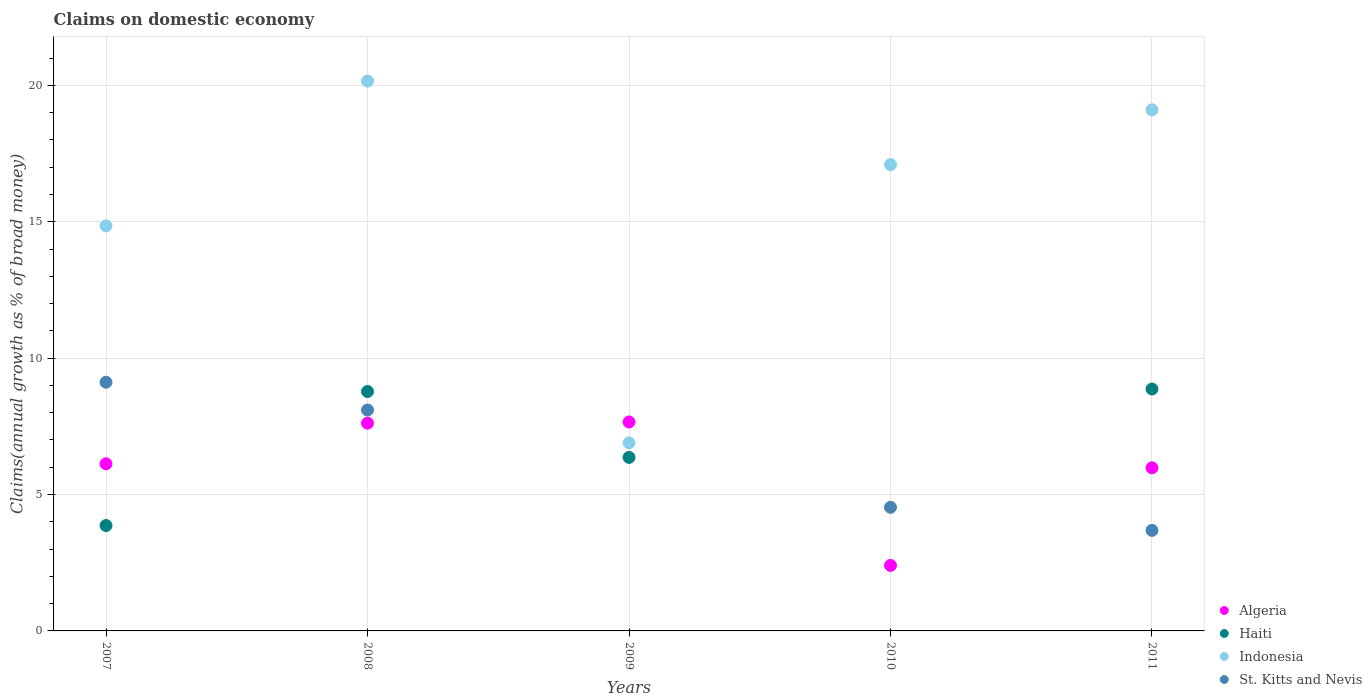How many different coloured dotlines are there?
Provide a succinct answer. 4. Is the number of dotlines equal to the number of legend labels?
Your answer should be compact. No. Across all years, what is the maximum percentage of broad money claimed on domestic economy in Indonesia?
Offer a terse response. 20.16. In which year was the percentage of broad money claimed on domestic economy in Algeria maximum?
Ensure brevity in your answer.  2009. What is the total percentage of broad money claimed on domestic economy in Indonesia in the graph?
Keep it short and to the point. 78.1. What is the difference between the percentage of broad money claimed on domestic economy in St. Kitts and Nevis in 2008 and that in 2010?
Your answer should be compact. 3.57. What is the difference between the percentage of broad money claimed on domestic economy in Algeria in 2010 and the percentage of broad money claimed on domestic economy in St. Kitts and Nevis in 2009?
Your answer should be compact. 2.4. What is the average percentage of broad money claimed on domestic economy in Haiti per year?
Provide a short and direct response. 5.57. In the year 2009, what is the difference between the percentage of broad money claimed on domestic economy in Haiti and percentage of broad money claimed on domestic economy in Indonesia?
Make the answer very short. -0.53. In how many years, is the percentage of broad money claimed on domestic economy in Haiti greater than 3 %?
Give a very brief answer. 4. What is the ratio of the percentage of broad money claimed on domestic economy in Indonesia in 2008 to that in 2011?
Give a very brief answer. 1.06. Is the percentage of broad money claimed on domestic economy in Haiti in 2009 less than that in 2011?
Keep it short and to the point. Yes. What is the difference between the highest and the second highest percentage of broad money claimed on domestic economy in Haiti?
Provide a succinct answer. 0.09. What is the difference between the highest and the lowest percentage of broad money claimed on domestic economy in St. Kitts and Nevis?
Keep it short and to the point. 9.12. In how many years, is the percentage of broad money claimed on domestic economy in Algeria greater than the average percentage of broad money claimed on domestic economy in Algeria taken over all years?
Offer a very short reply. 4. Is the sum of the percentage of broad money claimed on domestic economy in Haiti in 2009 and 2011 greater than the maximum percentage of broad money claimed on domestic economy in Algeria across all years?
Provide a succinct answer. Yes. Is the percentage of broad money claimed on domestic economy in Algeria strictly greater than the percentage of broad money claimed on domestic economy in Haiti over the years?
Provide a succinct answer. No. Is the percentage of broad money claimed on domestic economy in Algeria strictly less than the percentage of broad money claimed on domestic economy in St. Kitts and Nevis over the years?
Your response must be concise. No. How many years are there in the graph?
Provide a short and direct response. 5. Does the graph contain any zero values?
Give a very brief answer. Yes. How many legend labels are there?
Provide a short and direct response. 4. How are the legend labels stacked?
Make the answer very short. Vertical. What is the title of the graph?
Your answer should be very brief. Claims on domestic economy. Does "Nepal" appear as one of the legend labels in the graph?
Ensure brevity in your answer.  No. What is the label or title of the Y-axis?
Provide a succinct answer. Claims(annual growth as % of broad money). What is the Claims(annual growth as % of broad money) in Algeria in 2007?
Ensure brevity in your answer.  6.13. What is the Claims(annual growth as % of broad money) in Haiti in 2007?
Keep it short and to the point. 3.86. What is the Claims(annual growth as % of broad money) of Indonesia in 2007?
Provide a short and direct response. 14.85. What is the Claims(annual growth as % of broad money) of St. Kitts and Nevis in 2007?
Provide a short and direct response. 9.12. What is the Claims(annual growth as % of broad money) in Algeria in 2008?
Provide a short and direct response. 7.62. What is the Claims(annual growth as % of broad money) in Haiti in 2008?
Provide a short and direct response. 8.78. What is the Claims(annual growth as % of broad money) of Indonesia in 2008?
Make the answer very short. 20.16. What is the Claims(annual growth as % of broad money) in St. Kitts and Nevis in 2008?
Your answer should be very brief. 8.1. What is the Claims(annual growth as % of broad money) of Algeria in 2009?
Give a very brief answer. 7.66. What is the Claims(annual growth as % of broad money) of Haiti in 2009?
Offer a terse response. 6.36. What is the Claims(annual growth as % of broad money) in Indonesia in 2009?
Offer a terse response. 6.89. What is the Claims(annual growth as % of broad money) of Algeria in 2010?
Provide a succinct answer. 2.4. What is the Claims(annual growth as % of broad money) of Indonesia in 2010?
Provide a succinct answer. 17.1. What is the Claims(annual growth as % of broad money) in St. Kitts and Nevis in 2010?
Ensure brevity in your answer.  4.53. What is the Claims(annual growth as % of broad money) of Algeria in 2011?
Offer a terse response. 5.98. What is the Claims(annual growth as % of broad money) of Haiti in 2011?
Ensure brevity in your answer.  8.87. What is the Claims(annual growth as % of broad money) in Indonesia in 2011?
Your response must be concise. 19.1. What is the Claims(annual growth as % of broad money) of St. Kitts and Nevis in 2011?
Your response must be concise. 3.68. Across all years, what is the maximum Claims(annual growth as % of broad money) in Algeria?
Offer a terse response. 7.66. Across all years, what is the maximum Claims(annual growth as % of broad money) of Haiti?
Your answer should be compact. 8.87. Across all years, what is the maximum Claims(annual growth as % of broad money) of Indonesia?
Make the answer very short. 20.16. Across all years, what is the maximum Claims(annual growth as % of broad money) in St. Kitts and Nevis?
Your answer should be very brief. 9.12. Across all years, what is the minimum Claims(annual growth as % of broad money) in Algeria?
Ensure brevity in your answer.  2.4. Across all years, what is the minimum Claims(annual growth as % of broad money) of Haiti?
Ensure brevity in your answer.  0. Across all years, what is the minimum Claims(annual growth as % of broad money) in Indonesia?
Ensure brevity in your answer.  6.89. Across all years, what is the minimum Claims(annual growth as % of broad money) of St. Kitts and Nevis?
Ensure brevity in your answer.  0. What is the total Claims(annual growth as % of broad money) of Algeria in the graph?
Your response must be concise. 29.79. What is the total Claims(annual growth as % of broad money) of Haiti in the graph?
Your answer should be very brief. 27.87. What is the total Claims(annual growth as % of broad money) in Indonesia in the graph?
Give a very brief answer. 78.1. What is the total Claims(annual growth as % of broad money) in St. Kitts and Nevis in the graph?
Your answer should be very brief. 25.43. What is the difference between the Claims(annual growth as % of broad money) of Algeria in 2007 and that in 2008?
Provide a short and direct response. -1.49. What is the difference between the Claims(annual growth as % of broad money) in Haiti in 2007 and that in 2008?
Your response must be concise. -4.92. What is the difference between the Claims(annual growth as % of broad money) in Indonesia in 2007 and that in 2008?
Make the answer very short. -5.31. What is the difference between the Claims(annual growth as % of broad money) of St. Kitts and Nevis in 2007 and that in 2008?
Offer a terse response. 1.02. What is the difference between the Claims(annual growth as % of broad money) in Algeria in 2007 and that in 2009?
Offer a terse response. -1.53. What is the difference between the Claims(annual growth as % of broad money) of Haiti in 2007 and that in 2009?
Provide a short and direct response. -2.5. What is the difference between the Claims(annual growth as % of broad money) of Indonesia in 2007 and that in 2009?
Your response must be concise. 7.95. What is the difference between the Claims(annual growth as % of broad money) of Algeria in 2007 and that in 2010?
Your response must be concise. 3.73. What is the difference between the Claims(annual growth as % of broad money) of Indonesia in 2007 and that in 2010?
Offer a very short reply. -2.25. What is the difference between the Claims(annual growth as % of broad money) of St. Kitts and Nevis in 2007 and that in 2010?
Your answer should be compact. 4.59. What is the difference between the Claims(annual growth as % of broad money) of Algeria in 2007 and that in 2011?
Offer a terse response. 0.15. What is the difference between the Claims(annual growth as % of broad money) of Haiti in 2007 and that in 2011?
Your response must be concise. -5.01. What is the difference between the Claims(annual growth as % of broad money) in Indonesia in 2007 and that in 2011?
Offer a very short reply. -4.26. What is the difference between the Claims(annual growth as % of broad money) of St. Kitts and Nevis in 2007 and that in 2011?
Your answer should be very brief. 5.43. What is the difference between the Claims(annual growth as % of broad money) in Algeria in 2008 and that in 2009?
Make the answer very short. -0.04. What is the difference between the Claims(annual growth as % of broad money) in Haiti in 2008 and that in 2009?
Your answer should be very brief. 2.42. What is the difference between the Claims(annual growth as % of broad money) in Indonesia in 2008 and that in 2009?
Provide a short and direct response. 13.26. What is the difference between the Claims(annual growth as % of broad money) in Algeria in 2008 and that in 2010?
Keep it short and to the point. 5.22. What is the difference between the Claims(annual growth as % of broad money) in Indonesia in 2008 and that in 2010?
Keep it short and to the point. 3.06. What is the difference between the Claims(annual growth as % of broad money) of St. Kitts and Nevis in 2008 and that in 2010?
Provide a succinct answer. 3.57. What is the difference between the Claims(annual growth as % of broad money) in Algeria in 2008 and that in 2011?
Your response must be concise. 1.64. What is the difference between the Claims(annual growth as % of broad money) in Haiti in 2008 and that in 2011?
Provide a succinct answer. -0.09. What is the difference between the Claims(annual growth as % of broad money) of Indonesia in 2008 and that in 2011?
Your response must be concise. 1.05. What is the difference between the Claims(annual growth as % of broad money) in St. Kitts and Nevis in 2008 and that in 2011?
Ensure brevity in your answer.  4.41. What is the difference between the Claims(annual growth as % of broad money) of Algeria in 2009 and that in 2010?
Keep it short and to the point. 5.26. What is the difference between the Claims(annual growth as % of broad money) in Indonesia in 2009 and that in 2010?
Make the answer very short. -10.2. What is the difference between the Claims(annual growth as % of broad money) in Algeria in 2009 and that in 2011?
Your answer should be compact. 1.68. What is the difference between the Claims(annual growth as % of broad money) of Haiti in 2009 and that in 2011?
Make the answer very short. -2.51. What is the difference between the Claims(annual growth as % of broad money) of Indonesia in 2009 and that in 2011?
Provide a short and direct response. -12.21. What is the difference between the Claims(annual growth as % of broad money) of Algeria in 2010 and that in 2011?
Your answer should be very brief. -3.58. What is the difference between the Claims(annual growth as % of broad money) in Indonesia in 2010 and that in 2011?
Offer a terse response. -2.01. What is the difference between the Claims(annual growth as % of broad money) in St. Kitts and Nevis in 2010 and that in 2011?
Your response must be concise. 0.85. What is the difference between the Claims(annual growth as % of broad money) of Algeria in 2007 and the Claims(annual growth as % of broad money) of Haiti in 2008?
Offer a terse response. -2.65. What is the difference between the Claims(annual growth as % of broad money) in Algeria in 2007 and the Claims(annual growth as % of broad money) in Indonesia in 2008?
Make the answer very short. -14.03. What is the difference between the Claims(annual growth as % of broad money) of Algeria in 2007 and the Claims(annual growth as % of broad money) of St. Kitts and Nevis in 2008?
Offer a very short reply. -1.97. What is the difference between the Claims(annual growth as % of broad money) of Haiti in 2007 and the Claims(annual growth as % of broad money) of Indonesia in 2008?
Your answer should be compact. -16.3. What is the difference between the Claims(annual growth as % of broad money) in Haiti in 2007 and the Claims(annual growth as % of broad money) in St. Kitts and Nevis in 2008?
Make the answer very short. -4.24. What is the difference between the Claims(annual growth as % of broad money) in Indonesia in 2007 and the Claims(annual growth as % of broad money) in St. Kitts and Nevis in 2008?
Offer a terse response. 6.75. What is the difference between the Claims(annual growth as % of broad money) of Algeria in 2007 and the Claims(annual growth as % of broad money) of Haiti in 2009?
Ensure brevity in your answer.  -0.23. What is the difference between the Claims(annual growth as % of broad money) in Algeria in 2007 and the Claims(annual growth as % of broad money) in Indonesia in 2009?
Provide a succinct answer. -0.77. What is the difference between the Claims(annual growth as % of broad money) of Haiti in 2007 and the Claims(annual growth as % of broad money) of Indonesia in 2009?
Offer a terse response. -3.03. What is the difference between the Claims(annual growth as % of broad money) in Algeria in 2007 and the Claims(annual growth as % of broad money) in Indonesia in 2010?
Ensure brevity in your answer.  -10.97. What is the difference between the Claims(annual growth as % of broad money) of Algeria in 2007 and the Claims(annual growth as % of broad money) of St. Kitts and Nevis in 2010?
Offer a very short reply. 1.6. What is the difference between the Claims(annual growth as % of broad money) in Haiti in 2007 and the Claims(annual growth as % of broad money) in Indonesia in 2010?
Keep it short and to the point. -13.23. What is the difference between the Claims(annual growth as % of broad money) of Haiti in 2007 and the Claims(annual growth as % of broad money) of St. Kitts and Nevis in 2010?
Offer a very short reply. -0.67. What is the difference between the Claims(annual growth as % of broad money) in Indonesia in 2007 and the Claims(annual growth as % of broad money) in St. Kitts and Nevis in 2010?
Provide a succinct answer. 10.32. What is the difference between the Claims(annual growth as % of broad money) in Algeria in 2007 and the Claims(annual growth as % of broad money) in Haiti in 2011?
Your response must be concise. -2.74. What is the difference between the Claims(annual growth as % of broad money) of Algeria in 2007 and the Claims(annual growth as % of broad money) of Indonesia in 2011?
Your answer should be compact. -12.98. What is the difference between the Claims(annual growth as % of broad money) in Algeria in 2007 and the Claims(annual growth as % of broad money) in St. Kitts and Nevis in 2011?
Your answer should be very brief. 2.44. What is the difference between the Claims(annual growth as % of broad money) of Haiti in 2007 and the Claims(annual growth as % of broad money) of Indonesia in 2011?
Offer a terse response. -15.24. What is the difference between the Claims(annual growth as % of broad money) in Haiti in 2007 and the Claims(annual growth as % of broad money) in St. Kitts and Nevis in 2011?
Your response must be concise. 0.18. What is the difference between the Claims(annual growth as % of broad money) in Indonesia in 2007 and the Claims(annual growth as % of broad money) in St. Kitts and Nevis in 2011?
Ensure brevity in your answer.  11.16. What is the difference between the Claims(annual growth as % of broad money) in Algeria in 2008 and the Claims(annual growth as % of broad money) in Haiti in 2009?
Offer a terse response. 1.26. What is the difference between the Claims(annual growth as % of broad money) of Algeria in 2008 and the Claims(annual growth as % of broad money) of Indonesia in 2009?
Offer a very short reply. 0.72. What is the difference between the Claims(annual growth as % of broad money) of Haiti in 2008 and the Claims(annual growth as % of broad money) of Indonesia in 2009?
Provide a succinct answer. 1.88. What is the difference between the Claims(annual growth as % of broad money) in Algeria in 2008 and the Claims(annual growth as % of broad money) in Indonesia in 2010?
Offer a terse response. -9.48. What is the difference between the Claims(annual growth as % of broad money) in Algeria in 2008 and the Claims(annual growth as % of broad money) in St. Kitts and Nevis in 2010?
Ensure brevity in your answer.  3.09. What is the difference between the Claims(annual growth as % of broad money) of Haiti in 2008 and the Claims(annual growth as % of broad money) of Indonesia in 2010?
Your answer should be compact. -8.32. What is the difference between the Claims(annual growth as % of broad money) in Haiti in 2008 and the Claims(annual growth as % of broad money) in St. Kitts and Nevis in 2010?
Your answer should be very brief. 4.25. What is the difference between the Claims(annual growth as % of broad money) of Indonesia in 2008 and the Claims(annual growth as % of broad money) of St. Kitts and Nevis in 2010?
Your answer should be very brief. 15.63. What is the difference between the Claims(annual growth as % of broad money) of Algeria in 2008 and the Claims(annual growth as % of broad money) of Haiti in 2011?
Give a very brief answer. -1.25. What is the difference between the Claims(annual growth as % of broad money) in Algeria in 2008 and the Claims(annual growth as % of broad money) in Indonesia in 2011?
Keep it short and to the point. -11.49. What is the difference between the Claims(annual growth as % of broad money) in Algeria in 2008 and the Claims(annual growth as % of broad money) in St. Kitts and Nevis in 2011?
Offer a very short reply. 3.93. What is the difference between the Claims(annual growth as % of broad money) of Haiti in 2008 and the Claims(annual growth as % of broad money) of Indonesia in 2011?
Provide a succinct answer. -10.33. What is the difference between the Claims(annual growth as % of broad money) of Haiti in 2008 and the Claims(annual growth as % of broad money) of St. Kitts and Nevis in 2011?
Provide a succinct answer. 5.09. What is the difference between the Claims(annual growth as % of broad money) of Indonesia in 2008 and the Claims(annual growth as % of broad money) of St. Kitts and Nevis in 2011?
Provide a short and direct response. 16.47. What is the difference between the Claims(annual growth as % of broad money) of Algeria in 2009 and the Claims(annual growth as % of broad money) of Indonesia in 2010?
Offer a terse response. -9.44. What is the difference between the Claims(annual growth as % of broad money) of Algeria in 2009 and the Claims(annual growth as % of broad money) of St. Kitts and Nevis in 2010?
Your response must be concise. 3.13. What is the difference between the Claims(annual growth as % of broad money) of Haiti in 2009 and the Claims(annual growth as % of broad money) of Indonesia in 2010?
Your response must be concise. -10.73. What is the difference between the Claims(annual growth as % of broad money) of Haiti in 2009 and the Claims(annual growth as % of broad money) of St. Kitts and Nevis in 2010?
Ensure brevity in your answer.  1.83. What is the difference between the Claims(annual growth as % of broad money) in Indonesia in 2009 and the Claims(annual growth as % of broad money) in St. Kitts and Nevis in 2010?
Give a very brief answer. 2.36. What is the difference between the Claims(annual growth as % of broad money) in Algeria in 2009 and the Claims(annual growth as % of broad money) in Haiti in 2011?
Ensure brevity in your answer.  -1.21. What is the difference between the Claims(annual growth as % of broad money) in Algeria in 2009 and the Claims(annual growth as % of broad money) in Indonesia in 2011?
Your answer should be compact. -11.45. What is the difference between the Claims(annual growth as % of broad money) in Algeria in 2009 and the Claims(annual growth as % of broad money) in St. Kitts and Nevis in 2011?
Keep it short and to the point. 3.97. What is the difference between the Claims(annual growth as % of broad money) in Haiti in 2009 and the Claims(annual growth as % of broad money) in Indonesia in 2011?
Your response must be concise. -12.74. What is the difference between the Claims(annual growth as % of broad money) in Haiti in 2009 and the Claims(annual growth as % of broad money) in St. Kitts and Nevis in 2011?
Give a very brief answer. 2.68. What is the difference between the Claims(annual growth as % of broad money) in Indonesia in 2009 and the Claims(annual growth as % of broad money) in St. Kitts and Nevis in 2011?
Give a very brief answer. 3.21. What is the difference between the Claims(annual growth as % of broad money) of Algeria in 2010 and the Claims(annual growth as % of broad money) of Haiti in 2011?
Make the answer very short. -6.47. What is the difference between the Claims(annual growth as % of broad money) in Algeria in 2010 and the Claims(annual growth as % of broad money) in Indonesia in 2011?
Give a very brief answer. -16.7. What is the difference between the Claims(annual growth as % of broad money) in Algeria in 2010 and the Claims(annual growth as % of broad money) in St. Kitts and Nevis in 2011?
Keep it short and to the point. -1.28. What is the difference between the Claims(annual growth as % of broad money) in Indonesia in 2010 and the Claims(annual growth as % of broad money) in St. Kitts and Nevis in 2011?
Your answer should be very brief. 13.41. What is the average Claims(annual growth as % of broad money) of Algeria per year?
Offer a terse response. 5.96. What is the average Claims(annual growth as % of broad money) of Haiti per year?
Provide a succinct answer. 5.57. What is the average Claims(annual growth as % of broad money) in Indonesia per year?
Keep it short and to the point. 15.62. What is the average Claims(annual growth as % of broad money) of St. Kitts and Nevis per year?
Offer a terse response. 5.09. In the year 2007, what is the difference between the Claims(annual growth as % of broad money) of Algeria and Claims(annual growth as % of broad money) of Haiti?
Your response must be concise. 2.26. In the year 2007, what is the difference between the Claims(annual growth as % of broad money) of Algeria and Claims(annual growth as % of broad money) of Indonesia?
Provide a succinct answer. -8.72. In the year 2007, what is the difference between the Claims(annual growth as % of broad money) of Algeria and Claims(annual growth as % of broad money) of St. Kitts and Nevis?
Keep it short and to the point. -2.99. In the year 2007, what is the difference between the Claims(annual growth as % of broad money) in Haiti and Claims(annual growth as % of broad money) in Indonesia?
Your answer should be compact. -10.98. In the year 2007, what is the difference between the Claims(annual growth as % of broad money) of Haiti and Claims(annual growth as % of broad money) of St. Kitts and Nevis?
Provide a succinct answer. -5.25. In the year 2007, what is the difference between the Claims(annual growth as % of broad money) in Indonesia and Claims(annual growth as % of broad money) in St. Kitts and Nevis?
Provide a short and direct response. 5.73. In the year 2008, what is the difference between the Claims(annual growth as % of broad money) in Algeria and Claims(annual growth as % of broad money) in Haiti?
Provide a short and direct response. -1.16. In the year 2008, what is the difference between the Claims(annual growth as % of broad money) of Algeria and Claims(annual growth as % of broad money) of Indonesia?
Your answer should be very brief. -12.54. In the year 2008, what is the difference between the Claims(annual growth as % of broad money) of Algeria and Claims(annual growth as % of broad money) of St. Kitts and Nevis?
Offer a terse response. -0.48. In the year 2008, what is the difference between the Claims(annual growth as % of broad money) in Haiti and Claims(annual growth as % of broad money) in Indonesia?
Your response must be concise. -11.38. In the year 2008, what is the difference between the Claims(annual growth as % of broad money) of Haiti and Claims(annual growth as % of broad money) of St. Kitts and Nevis?
Your response must be concise. 0.68. In the year 2008, what is the difference between the Claims(annual growth as % of broad money) in Indonesia and Claims(annual growth as % of broad money) in St. Kitts and Nevis?
Provide a succinct answer. 12.06. In the year 2009, what is the difference between the Claims(annual growth as % of broad money) in Algeria and Claims(annual growth as % of broad money) in Haiti?
Your answer should be very brief. 1.3. In the year 2009, what is the difference between the Claims(annual growth as % of broad money) of Algeria and Claims(annual growth as % of broad money) of Indonesia?
Your answer should be compact. 0.77. In the year 2009, what is the difference between the Claims(annual growth as % of broad money) of Haiti and Claims(annual growth as % of broad money) of Indonesia?
Give a very brief answer. -0.53. In the year 2010, what is the difference between the Claims(annual growth as % of broad money) in Algeria and Claims(annual growth as % of broad money) in Indonesia?
Offer a very short reply. -14.69. In the year 2010, what is the difference between the Claims(annual growth as % of broad money) in Algeria and Claims(annual growth as % of broad money) in St. Kitts and Nevis?
Your answer should be very brief. -2.13. In the year 2010, what is the difference between the Claims(annual growth as % of broad money) of Indonesia and Claims(annual growth as % of broad money) of St. Kitts and Nevis?
Ensure brevity in your answer.  12.56. In the year 2011, what is the difference between the Claims(annual growth as % of broad money) of Algeria and Claims(annual growth as % of broad money) of Haiti?
Give a very brief answer. -2.89. In the year 2011, what is the difference between the Claims(annual growth as % of broad money) of Algeria and Claims(annual growth as % of broad money) of Indonesia?
Your answer should be compact. -13.12. In the year 2011, what is the difference between the Claims(annual growth as % of broad money) in Algeria and Claims(annual growth as % of broad money) in St. Kitts and Nevis?
Your answer should be compact. 2.3. In the year 2011, what is the difference between the Claims(annual growth as % of broad money) in Haiti and Claims(annual growth as % of broad money) in Indonesia?
Keep it short and to the point. -10.24. In the year 2011, what is the difference between the Claims(annual growth as % of broad money) in Haiti and Claims(annual growth as % of broad money) in St. Kitts and Nevis?
Provide a short and direct response. 5.18. In the year 2011, what is the difference between the Claims(annual growth as % of broad money) of Indonesia and Claims(annual growth as % of broad money) of St. Kitts and Nevis?
Offer a very short reply. 15.42. What is the ratio of the Claims(annual growth as % of broad money) of Algeria in 2007 to that in 2008?
Keep it short and to the point. 0.8. What is the ratio of the Claims(annual growth as % of broad money) in Haiti in 2007 to that in 2008?
Your answer should be very brief. 0.44. What is the ratio of the Claims(annual growth as % of broad money) of Indonesia in 2007 to that in 2008?
Your answer should be compact. 0.74. What is the ratio of the Claims(annual growth as % of broad money) of St. Kitts and Nevis in 2007 to that in 2008?
Provide a succinct answer. 1.13. What is the ratio of the Claims(annual growth as % of broad money) of Haiti in 2007 to that in 2009?
Your answer should be compact. 0.61. What is the ratio of the Claims(annual growth as % of broad money) in Indonesia in 2007 to that in 2009?
Make the answer very short. 2.15. What is the ratio of the Claims(annual growth as % of broad money) in Algeria in 2007 to that in 2010?
Your answer should be very brief. 2.55. What is the ratio of the Claims(annual growth as % of broad money) in Indonesia in 2007 to that in 2010?
Provide a short and direct response. 0.87. What is the ratio of the Claims(annual growth as % of broad money) of St. Kitts and Nevis in 2007 to that in 2010?
Your answer should be compact. 2.01. What is the ratio of the Claims(annual growth as % of broad money) in Algeria in 2007 to that in 2011?
Your answer should be very brief. 1.02. What is the ratio of the Claims(annual growth as % of broad money) in Haiti in 2007 to that in 2011?
Offer a terse response. 0.44. What is the ratio of the Claims(annual growth as % of broad money) in Indonesia in 2007 to that in 2011?
Keep it short and to the point. 0.78. What is the ratio of the Claims(annual growth as % of broad money) of St. Kitts and Nevis in 2007 to that in 2011?
Give a very brief answer. 2.47. What is the ratio of the Claims(annual growth as % of broad money) of Algeria in 2008 to that in 2009?
Offer a terse response. 0.99. What is the ratio of the Claims(annual growth as % of broad money) of Haiti in 2008 to that in 2009?
Give a very brief answer. 1.38. What is the ratio of the Claims(annual growth as % of broad money) of Indonesia in 2008 to that in 2009?
Ensure brevity in your answer.  2.92. What is the ratio of the Claims(annual growth as % of broad money) of Algeria in 2008 to that in 2010?
Ensure brevity in your answer.  3.17. What is the ratio of the Claims(annual growth as % of broad money) of Indonesia in 2008 to that in 2010?
Keep it short and to the point. 1.18. What is the ratio of the Claims(annual growth as % of broad money) in St. Kitts and Nevis in 2008 to that in 2010?
Make the answer very short. 1.79. What is the ratio of the Claims(annual growth as % of broad money) of Algeria in 2008 to that in 2011?
Offer a terse response. 1.27. What is the ratio of the Claims(annual growth as % of broad money) of Indonesia in 2008 to that in 2011?
Give a very brief answer. 1.06. What is the ratio of the Claims(annual growth as % of broad money) of St. Kitts and Nevis in 2008 to that in 2011?
Give a very brief answer. 2.2. What is the ratio of the Claims(annual growth as % of broad money) in Algeria in 2009 to that in 2010?
Provide a succinct answer. 3.19. What is the ratio of the Claims(annual growth as % of broad money) of Indonesia in 2009 to that in 2010?
Give a very brief answer. 0.4. What is the ratio of the Claims(annual growth as % of broad money) of Algeria in 2009 to that in 2011?
Offer a very short reply. 1.28. What is the ratio of the Claims(annual growth as % of broad money) of Haiti in 2009 to that in 2011?
Your answer should be compact. 0.72. What is the ratio of the Claims(annual growth as % of broad money) of Indonesia in 2009 to that in 2011?
Provide a short and direct response. 0.36. What is the ratio of the Claims(annual growth as % of broad money) in Algeria in 2010 to that in 2011?
Keep it short and to the point. 0.4. What is the ratio of the Claims(annual growth as % of broad money) of Indonesia in 2010 to that in 2011?
Make the answer very short. 0.89. What is the ratio of the Claims(annual growth as % of broad money) of St. Kitts and Nevis in 2010 to that in 2011?
Your response must be concise. 1.23. What is the difference between the highest and the second highest Claims(annual growth as % of broad money) of Algeria?
Give a very brief answer. 0.04. What is the difference between the highest and the second highest Claims(annual growth as % of broad money) in Haiti?
Ensure brevity in your answer.  0.09. What is the difference between the highest and the second highest Claims(annual growth as % of broad money) of Indonesia?
Your answer should be very brief. 1.05. What is the difference between the highest and the second highest Claims(annual growth as % of broad money) in St. Kitts and Nevis?
Your answer should be compact. 1.02. What is the difference between the highest and the lowest Claims(annual growth as % of broad money) of Algeria?
Ensure brevity in your answer.  5.26. What is the difference between the highest and the lowest Claims(annual growth as % of broad money) in Haiti?
Your response must be concise. 8.87. What is the difference between the highest and the lowest Claims(annual growth as % of broad money) of Indonesia?
Provide a succinct answer. 13.26. What is the difference between the highest and the lowest Claims(annual growth as % of broad money) of St. Kitts and Nevis?
Your answer should be very brief. 9.12. 